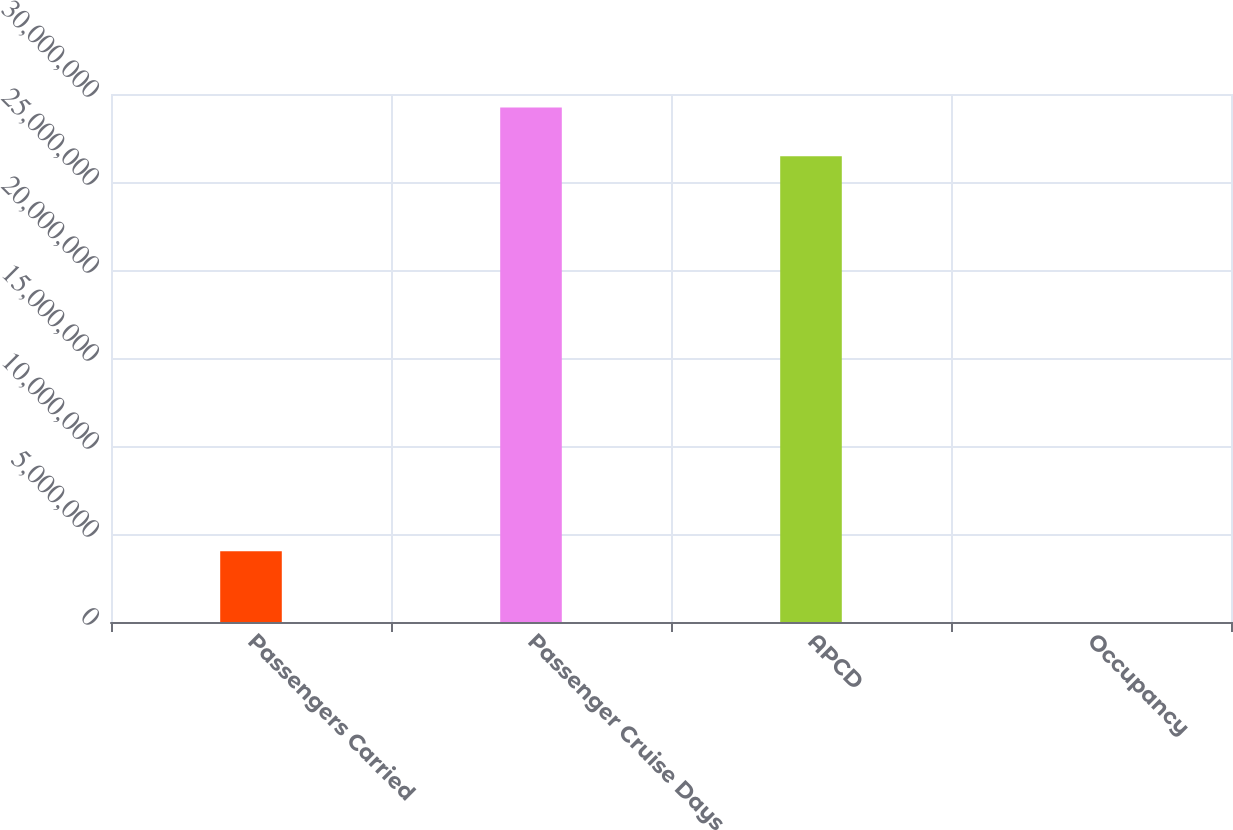Convert chart to OTSL. <chart><loc_0><loc_0><loc_500><loc_500><bar_chart><fcel>Passengers Carried<fcel>Passenger Cruise Days<fcel>APCD<fcel>Occupancy<nl><fcel>4.01755e+06<fcel>2.92294e+07<fcel>2.64636e+07<fcel>104.5<nl></chart> 